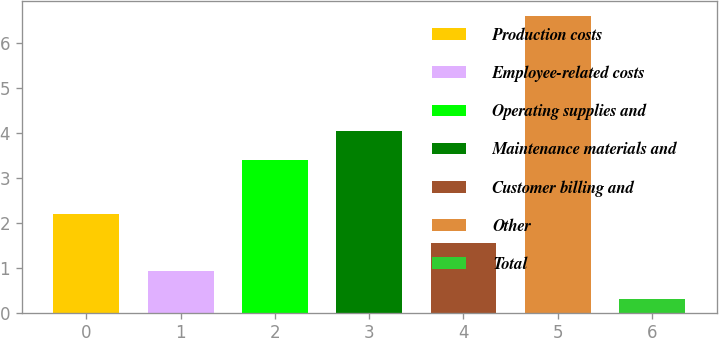Convert chart. <chart><loc_0><loc_0><loc_500><loc_500><bar_chart><fcel>Production costs<fcel>Employee-related costs<fcel>Operating supplies and<fcel>Maintenance materials and<fcel>Customer billing and<fcel>Other<fcel>Total<nl><fcel>2.2<fcel>0.93<fcel>3.4<fcel>4.03<fcel>1.56<fcel>6.6<fcel>0.3<nl></chart> 